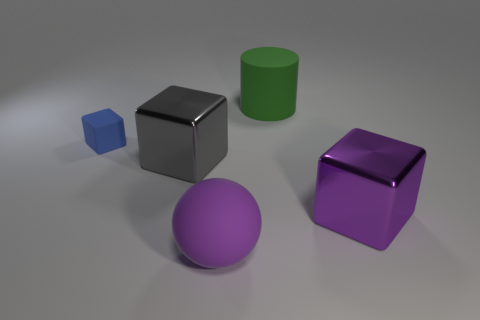Add 3 green rubber things. How many objects exist? 8 Subtract all cylinders. How many objects are left? 4 Subtract all small blue rubber objects. Subtract all green matte cylinders. How many objects are left? 3 Add 5 big blocks. How many big blocks are left? 7 Add 3 big purple blocks. How many big purple blocks exist? 4 Subtract 0 gray cylinders. How many objects are left? 5 